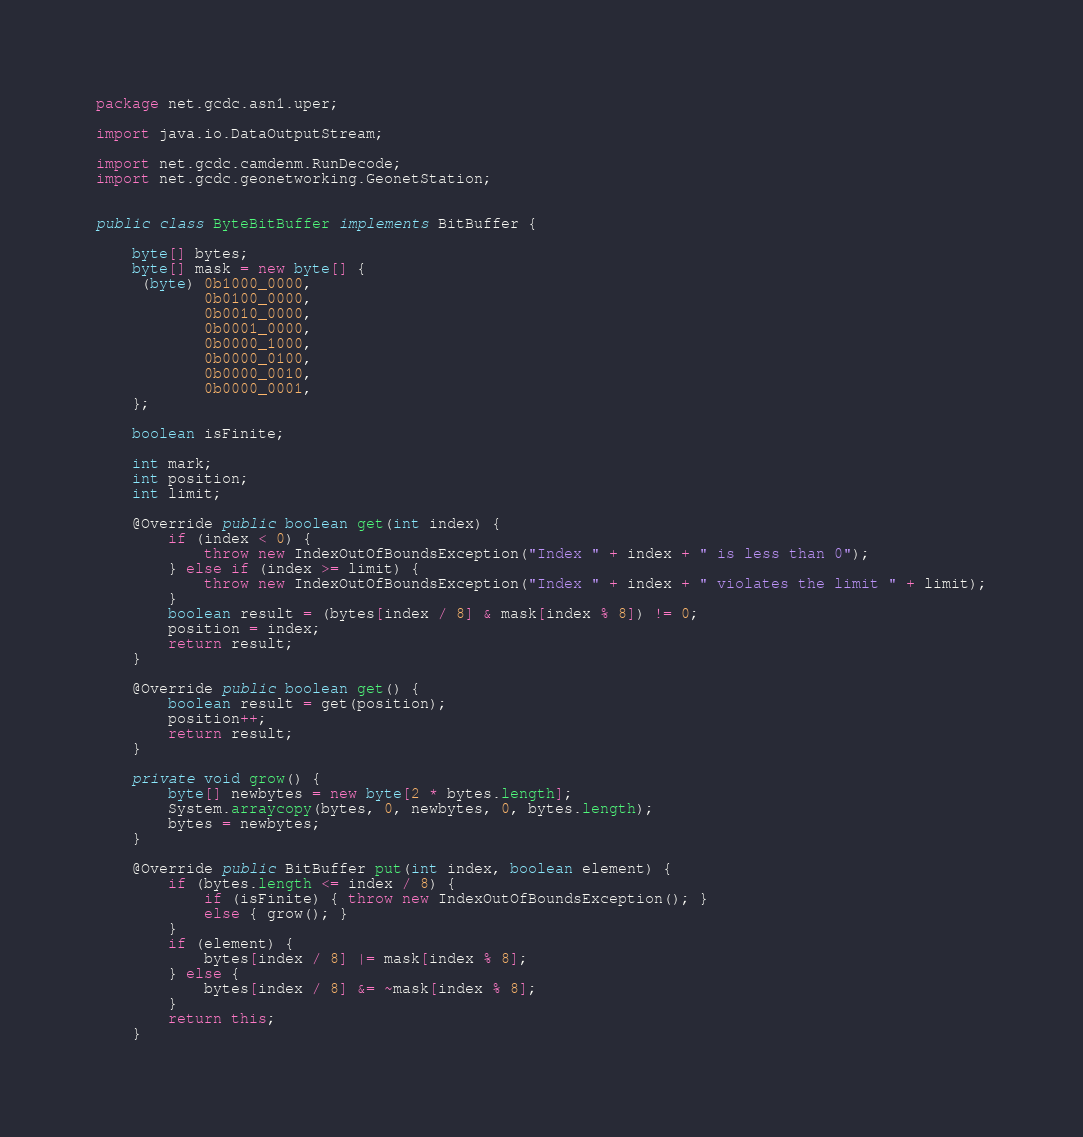<code> <loc_0><loc_0><loc_500><loc_500><_Java_>package net.gcdc.asn1.uper;

import java.io.DataOutputStream;

import net.gcdc.camdenm.RunDecode;
import net.gcdc.geonetworking.GeonetStation;


public class ByteBitBuffer implements BitBuffer {

    byte[] bytes;
    byte[] mask = new byte[] {
     (byte) 0b1000_0000,
            0b0100_0000,
            0b0010_0000,
            0b0001_0000,
            0b0000_1000,
            0b0000_0100,
            0b0000_0010,
            0b0000_0001,
    };

    boolean isFinite;

    int mark;
    int position;
    int limit;

    @Override public boolean get(int index) {
        if (index < 0) {
            throw new IndexOutOfBoundsException("Index " + index + " is less than 0");
        } else if (index >= limit) {
            throw new IndexOutOfBoundsException("Index " + index + " violates the limit " + limit);
        }
        boolean result = (bytes[index / 8] & mask[index % 8]) != 0;
        position = index;
        return result;
    }

    @Override public boolean get() {
        boolean result = get(position);
        position++;
        return result;
    }

    private void grow() {
        byte[] newbytes = new byte[2 * bytes.length];
        System.arraycopy(bytes, 0, newbytes, 0, bytes.length);
        bytes = newbytes;
    }

    @Override public BitBuffer put(int index, boolean element) {
        if (bytes.length <= index / 8) {
            if (isFinite) { throw new IndexOutOfBoundsException(); }
            else { grow(); }
        }
        if (element) {
            bytes[index / 8] |= mask[index % 8];
        } else {
            bytes[index / 8] &= ~mask[index % 8];
        }
        return this;
    }
</code> 